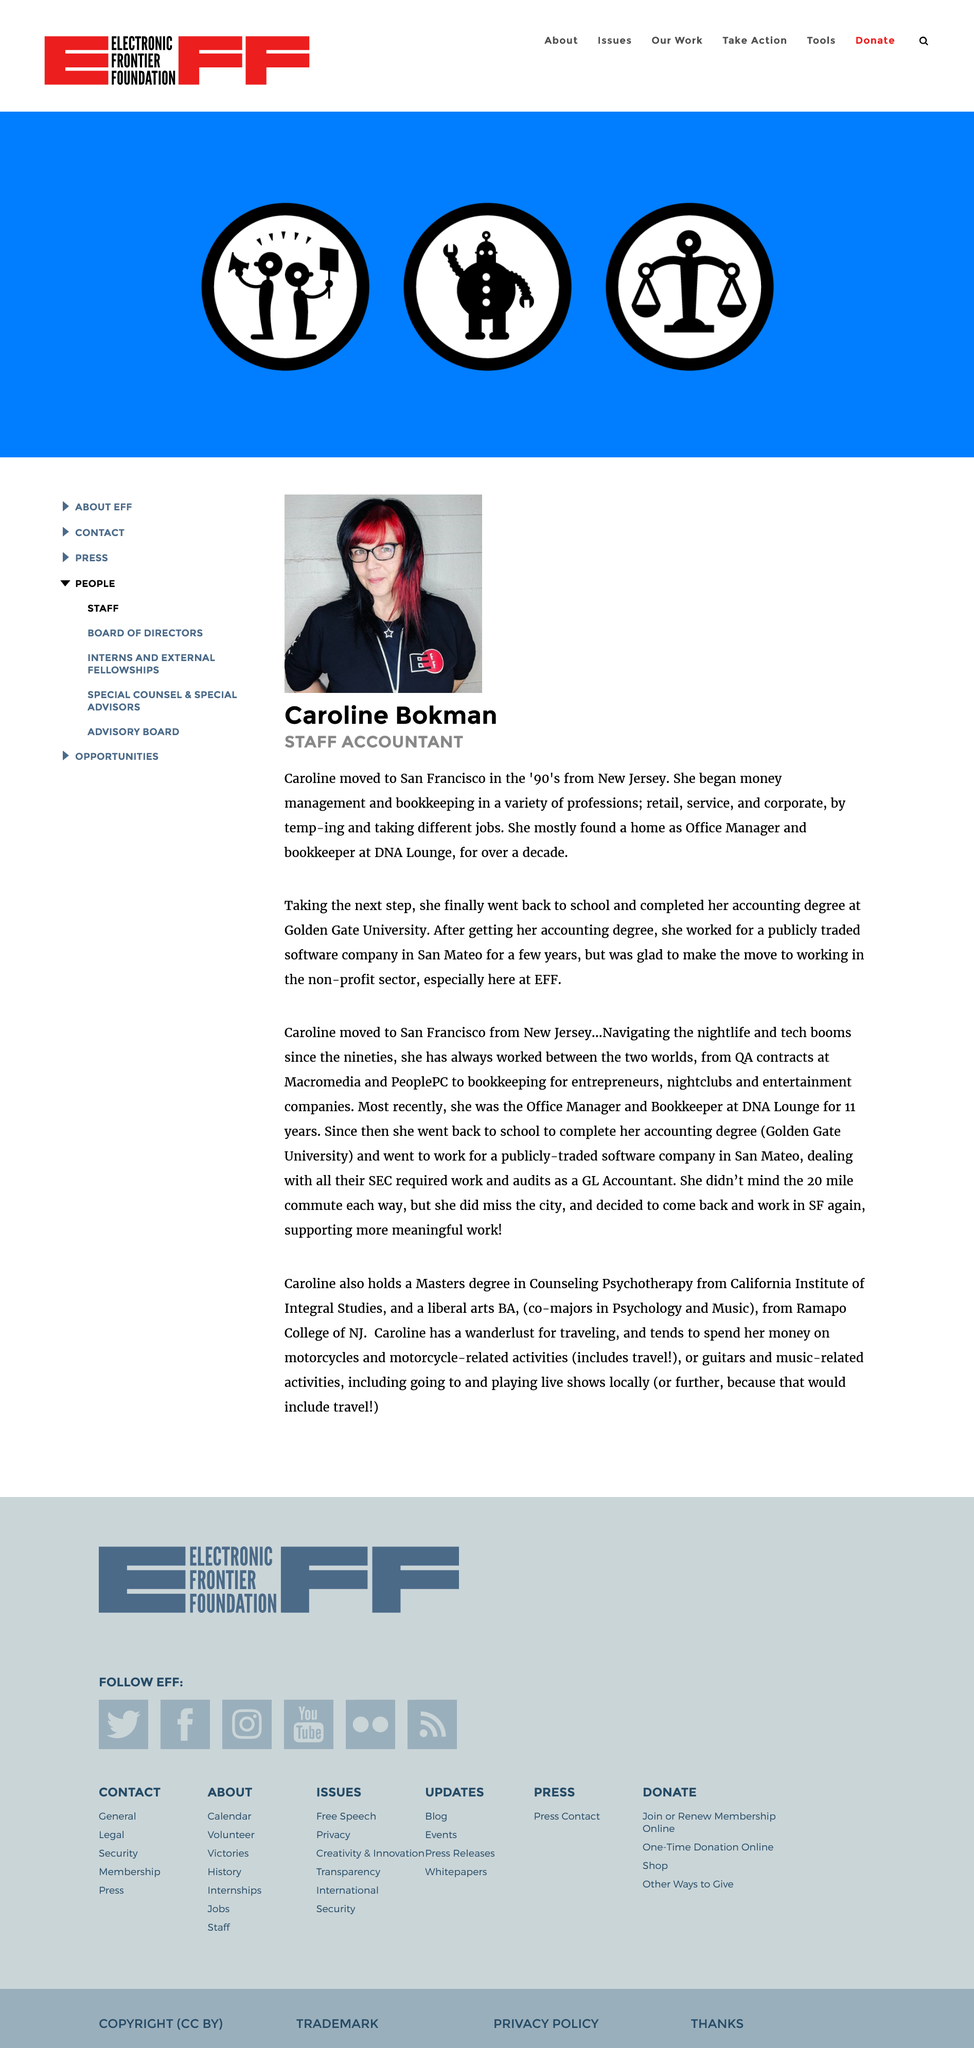List a handful of essential elements in this visual. The image depicts a woman named Caroline Bokman. During the past decade, the individual in question performed the job of office manager and bookkeeper. The subject is asking about the location where the person completed their accounting degree. The subject is looking for specific information about the location of the accounting degree. The subject is not looking for additional information about the person or the degree. 